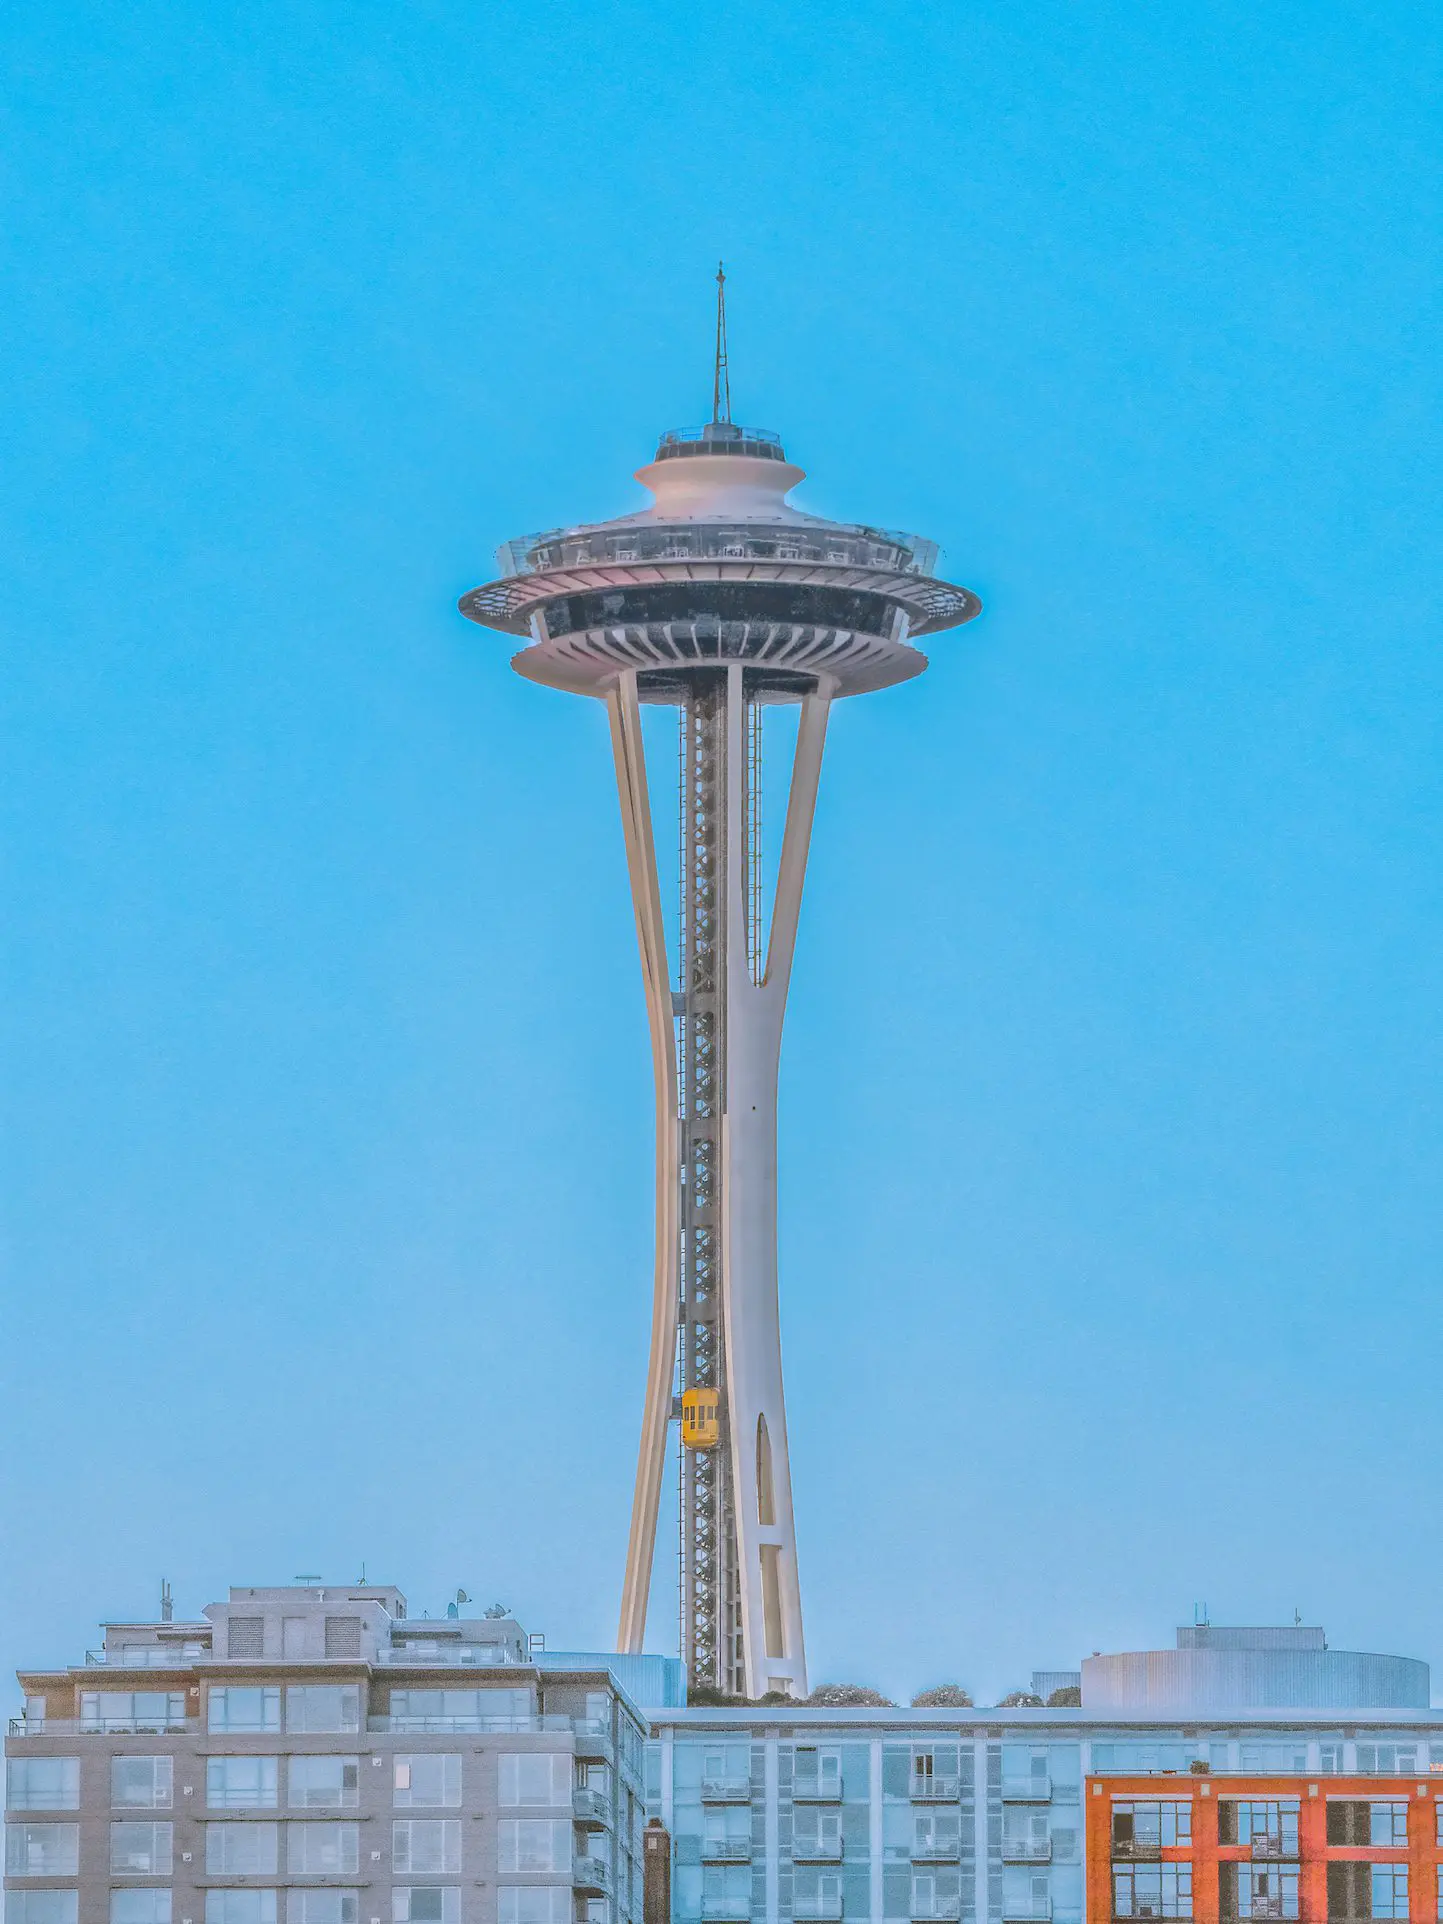How would you describe the atmosphere captured in this photo? The atmosphere in the photo is one of serene tranquility and majestic awe. The clear blue sky evokes a sense of calm and peace, contrasting beautifully with the bold and impressive stature of the Space Needle. The warm light reflecting off the structure adds a touch of warmth and vibrancy to the otherwise cool-toned scene. This juxtaposition creates a balanced and visually appealing image that captures the magnificence and tranquility of a quiet day in Seattle. Can you provide a short commentary on the architectural style of the Space Needle? The Space Needle is an exemplary piece of Googie architecture, inspired by the Space Age and futuristic design concepts of the 1960s. Its sleek, elongated silhouette, flying saucer-shaped observation deck, and use of modern materials like steel and glass embody the optimism and forward-thinking vision of the era. Its design marries form and function, making it a lasting symbol of innovation and architectural brilliance. Could you imagine the Space Needle in the context of a storyline involving time travel? Certainly! Imagine a scenario where the Space Needle functions as a covert time portal, its observation deck a gateway to different epochs. A group of oblivious tourists stumbles upon an ancient script hidden in the decor, revealing the secret. As they decipher its meaning, they are transported through time – one moment, they're experiencing Seattle in the roaring 1920s, and the next, they're witnessing the city's growth in 2099. Throughout their journey, the Space Needle anchors them, ensuring they can always return to their present. This intertwines their adventures across different eras with the constancy of this iconic landmark. Describe a short, realistic scenario in which the Space Needle plays a central role. Imagine a sunny day in Seattle with a gentle breeze swaying through the air. Tourists line up excitedly to ride the elevator to the top of the Space Needle. A family celebrates a birthday at the rotating restaurant, enjoying meals while soaking in the breathtaking 360-degree views of the cityscape, mountains, and open waters. Beneath them, children at the Seattle Center are enjoying the nearby attractions, and locals appreciate the sunny day. The Space Needle stands as a timeless beacon, drawing people from all walks of life to marvel at its splendor and the vibrant city it oversees. Can you give a detailed and imaginative description of an artistic event centered around the Space Needle? Picture a twilight soirée, 'Luminescence at the Needle,' where the Space Needle becomes the canvas for an avant-garde light exhibition. As dusk settles, the landmark bursts into life, adorned with a mesmerizing display of colors, patterns, and projections. Artists from around the globe have contributed, turning the structure into an ever-changing spectacle of digital art. Interactive installations at its base allow visitors to influence the projections, adding a personal touch to the art. Meanwhile, musicians perform ethereal compositions that complement the visual feast, creating an immersive, multisensory experience. Food and drink stalls offer gourmet delights, ensuring the event tantalizes all senses. This celebration is a homage to art, technology, and the iconic Space Needle, uniting people in an unforgettable night of creativity and wonder. 